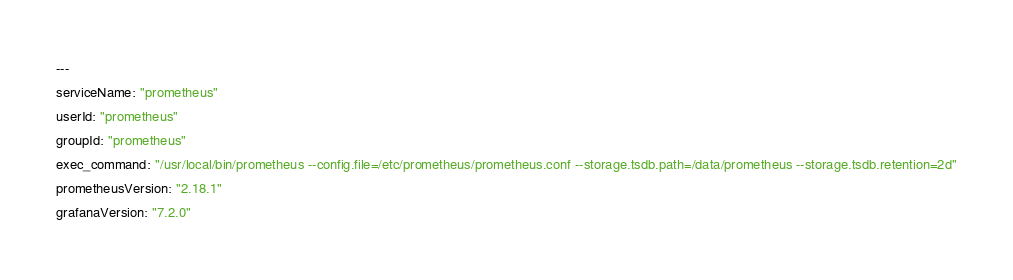Convert code to text. <code><loc_0><loc_0><loc_500><loc_500><_YAML_>---
serviceName: "prometheus"
userId: "prometheus"
groupId: "prometheus"
exec_command: "/usr/local/bin/prometheus --config.file=/etc/prometheus/prometheus.conf --storage.tsdb.path=/data/prometheus --storage.tsdb.retention=2d"
prometheusVersion: "2.18.1"
grafanaVersion: "7.2.0"
</code> 